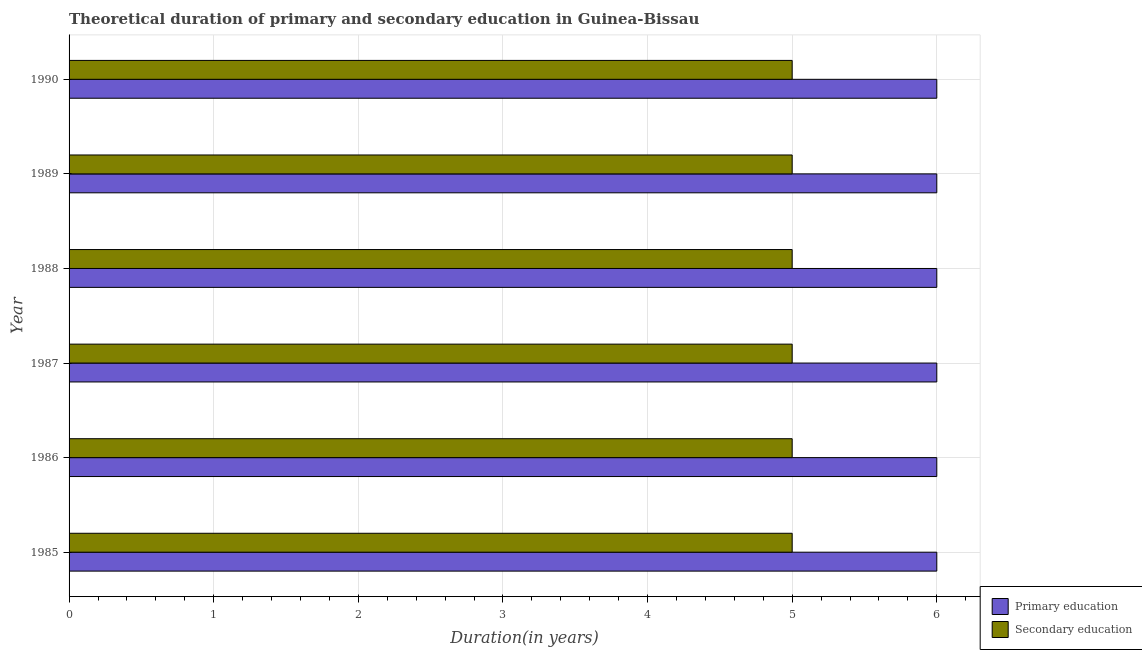How many groups of bars are there?
Your answer should be very brief. 6. Are the number of bars per tick equal to the number of legend labels?
Your answer should be very brief. Yes. Are the number of bars on each tick of the Y-axis equal?
Your answer should be compact. Yes. How many bars are there on the 5th tick from the top?
Your response must be concise. 2. What is the duration of secondary education in 1987?
Your answer should be very brief. 5. Across all years, what is the maximum duration of primary education?
Your response must be concise. 6. What is the total duration of primary education in the graph?
Offer a very short reply. 36. What is the difference between the duration of primary education in 1989 and the duration of secondary education in 1987?
Offer a terse response. 1. What is the average duration of secondary education per year?
Provide a succinct answer. 5. In the year 1987, what is the difference between the duration of secondary education and duration of primary education?
Offer a very short reply. -1. In how many years, is the duration of primary education greater than 5.2 years?
Your answer should be compact. 6. Is the duration of secondary education in 1986 less than that in 1990?
Make the answer very short. No. Is the difference between the duration of secondary education in 1985 and 1990 greater than the difference between the duration of primary education in 1985 and 1990?
Give a very brief answer. No. What is the difference between the highest and the second highest duration of secondary education?
Your response must be concise. 0. What is the difference between the highest and the lowest duration of secondary education?
Keep it short and to the point. 0. In how many years, is the duration of secondary education greater than the average duration of secondary education taken over all years?
Your response must be concise. 0. What does the 1st bar from the top in 1988 represents?
Make the answer very short. Secondary education. What does the 2nd bar from the bottom in 1985 represents?
Offer a very short reply. Secondary education. How many bars are there?
Provide a succinct answer. 12. How many years are there in the graph?
Offer a terse response. 6. Are the values on the major ticks of X-axis written in scientific E-notation?
Ensure brevity in your answer.  No. Does the graph contain any zero values?
Give a very brief answer. No. Does the graph contain grids?
Ensure brevity in your answer.  Yes. Where does the legend appear in the graph?
Keep it short and to the point. Bottom right. How are the legend labels stacked?
Give a very brief answer. Vertical. What is the title of the graph?
Your answer should be very brief. Theoretical duration of primary and secondary education in Guinea-Bissau. What is the label or title of the X-axis?
Give a very brief answer. Duration(in years). What is the Duration(in years) of Primary education in 1986?
Provide a succinct answer. 6. What is the Duration(in years) in Secondary education in 1988?
Your response must be concise. 5. What is the Duration(in years) in Secondary education in 1990?
Keep it short and to the point. 5. Across all years, what is the minimum Duration(in years) in Primary education?
Make the answer very short. 6. Across all years, what is the minimum Duration(in years) of Secondary education?
Offer a terse response. 5. What is the difference between the Duration(in years) of Primary education in 1985 and that in 1986?
Keep it short and to the point. 0. What is the difference between the Duration(in years) of Secondary education in 1985 and that in 1986?
Give a very brief answer. 0. What is the difference between the Duration(in years) in Primary education in 1985 and that in 1987?
Your response must be concise. 0. What is the difference between the Duration(in years) of Secondary education in 1985 and that in 1987?
Your answer should be compact. 0. What is the difference between the Duration(in years) in Primary education in 1985 and that in 1988?
Offer a terse response. 0. What is the difference between the Duration(in years) of Secondary education in 1985 and that in 1988?
Keep it short and to the point. 0. What is the difference between the Duration(in years) of Primary education in 1985 and that in 1989?
Offer a terse response. 0. What is the difference between the Duration(in years) in Secondary education in 1985 and that in 1989?
Provide a succinct answer. 0. What is the difference between the Duration(in years) in Secondary education in 1985 and that in 1990?
Ensure brevity in your answer.  0. What is the difference between the Duration(in years) of Secondary education in 1986 and that in 1987?
Offer a very short reply. 0. What is the difference between the Duration(in years) of Secondary education in 1986 and that in 1989?
Your answer should be very brief. 0. What is the difference between the Duration(in years) of Secondary education in 1986 and that in 1990?
Your answer should be compact. 0. What is the difference between the Duration(in years) in Secondary education in 1987 and that in 1988?
Give a very brief answer. 0. What is the difference between the Duration(in years) of Secondary education in 1987 and that in 1990?
Your response must be concise. 0. What is the difference between the Duration(in years) of Secondary education in 1988 and that in 1989?
Give a very brief answer. 0. What is the difference between the Duration(in years) in Secondary education in 1988 and that in 1990?
Keep it short and to the point. 0. What is the difference between the Duration(in years) of Primary education in 1989 and that in 1990?
Keep it short and to the point. 0. What is the difference between the Duration(in years) of Primary education in 1985 and the Duration(in years) of Secondary education in 1986?
Provide a short and direct response. 1. What is the difference between the Duration(in years) in Primary education in 1985 and the Duration(in years) in Secondary education in 1990?
Your answer should be very brief. 1. What is the difference between the Duration(in years) of Primary education in 1986 and the Duration(in years) of Secondary education in 1987?
Keep it short and to the point. 1. What is the difference between the Duration(in years) of Primary education in 1986 and the Duration(in years) of Secondary education in 1988?
Your answer should be compact. 1. What is the difference between the Duration(in years) in Primary education in 1987 and the Duration(in years) in Secondary education in 1988?
Offer a terse response. 1. What is the difference between the Duration(in years) in Primary education in 1987 and the Duration(in years) in Secondary education in 1990?
Give a very brief answer. 1. What is the difference between the Duration(in years) in Primary education in 1988 and the Duration(in years) in Secondary education in 1989?
Offer a very short reply. 1. What is the difference between the Duration(in years) of Primary education in 1988 and the Duration(in years) of Secondary education in 1990?
Your answer should be very brief. 1. What is the average Duration(in years) in Secondary education per year?
Your response must be concise. 5. In the year 1987, what is the difference between the Duration(in years) in Primary education and Duration(in years) in Secondary education?
Your answer should be very brief. 1. In the year 1988, what is the difference between the Duration(in years) of Primary education and Duration(in years) of Secondary education?
Provide a succinct answer. 1. What is the ratio of the Duration(in years) of Primary education in 1985 to that in 1986?
Your response must be concise. 1. What is the ratio of the Duration(in years) in Primary education in 1985 to that in 1987?
Your answer should be very brief. 1. What is the ratio of the Duration(in years) in Secondary education in 1985 to that in 1987?
Your response must be concise. 1. What is the ratio of the Duration(in years) of Primary education in 1985 to that in 1988?
Provide a short and direct response. 1. What is the ratio of the Duration(in years) in Secondary education in 1985 to that in 1988?
Ensure brevity in your answer.  1. What is the ratio of the Duration(in years) of Primary education in 1985 to that in 1989?
Ensure brevity in your answer.  1. What is the ratio of the Duration(in years) of Secondary education in 1985 to that in 1989?
Offer a terse response. 1. What is the ratio of the Duration(in years) in Secondary education in 1985 to that in 1990?
Provide a short and direct response. 1. What is the ratio of the Duration(in years) in Primary education in 1986 to that in 1987?
Your answer should be very brief. 1. What is the ratio of the Duration(in years) in Secondary education in 1986 to that in 1987?
Provide a short and direct response. 1. What is the ratio of the Duration(in years) of Primary education in 1986 to that in 1989?
Offer a very short reply. 1. What is the ratio of the Duration(in years) of Secondary education in 1986 to that in 1990?
Ensure brevity in your answer.  1. What is the ratio of the Duration(in years) of Primary education in 1987 to that in 1988?
Provide a short and direct response. 1. What is the ratio of the Duration(in years) in Secondary education in 1987 to that in 1988?
Your answer should be compact. 1. What is the ratio of the Duration(in years) of Primary education in 1987 to that in 1989?
Offer a very short reply. 1. What is the ratio of the Duration(in years) in Secondary education in 1987 to that in 1989?
Make the answer very short. 1. What is the ratio of the Duration(in years) in Primary education in 1987 to that in 1990?
Provide a succinct answer. 1. What is the ratio of the Duration(in years) in Secondary education in 1987 to that in 1990?
Your answer should be compact. 1. What is the ratio of the Duration(in years) of Secondary education in 1988 to that in 1989?
Give a very brief answer. 1. What is the ratio of the Duration(in years) in Primary education in 1988 to that in 1990?
Offer a very short reply. 1. What is the ratio of the Duration(in years) of Primary education in 1989 to that in 1990?
Provide a short and direct response. 1. What is the ratio of the Duration(in years) of Secondary education in 1989 to that in 1990?
Provide a short and direct response. 1. 